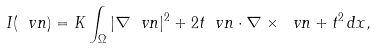<formula> <loc_0><loc_0><loc_500><loc_500>I ( \ v n ) = K \int _ { \Omega } | \nabla \ v n | ^ { 2 } + 2 t \ v n \cdot \nabla \times \ v n + t ^ { 2 } \, d x ,</formula> 